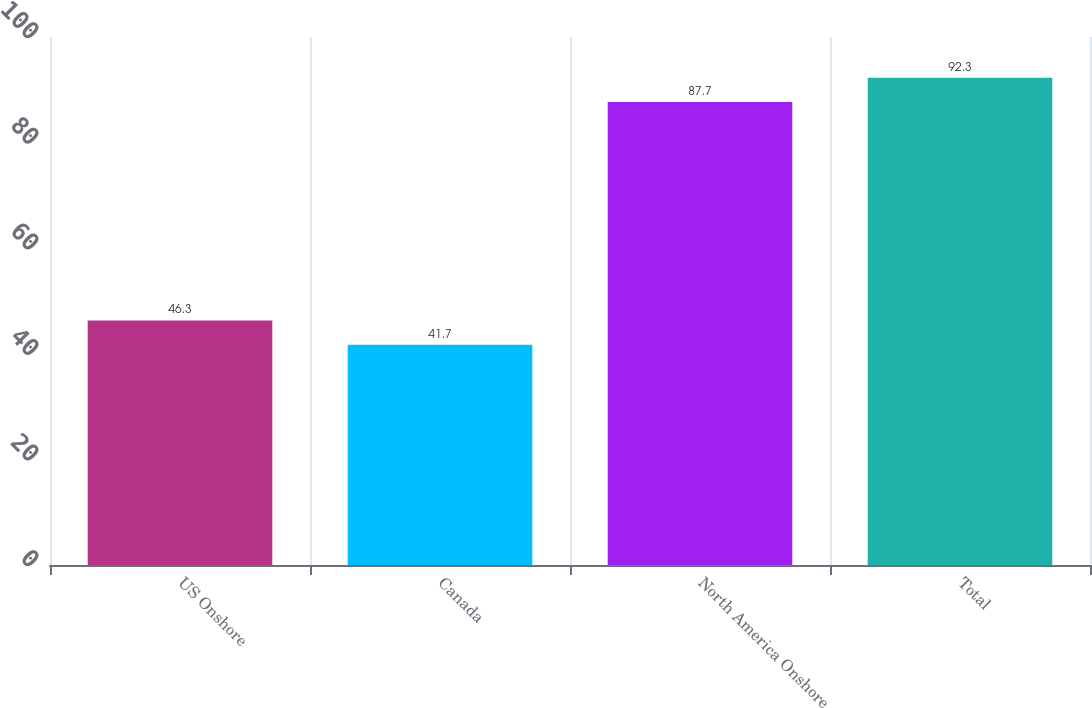Convert chart. <chart><loc_0><loc_0><loc_500><loc_500><bar_chart><fcel>US Onshore<fcel>Canada<fcel>North America Onshore<fcel>Total<nl><fcel>46.3<fcel>41.7<fcel>87.7<fcel>92.3<nl></chart> 